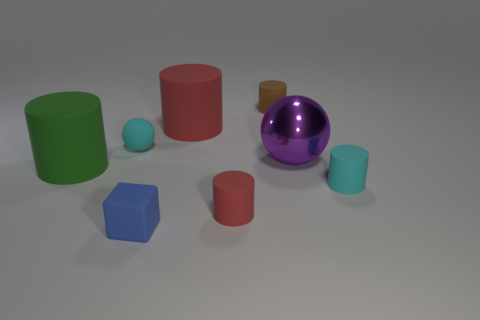Subtract all big red matte cylinders. How many cylinders are left? 4 Subtract all red cylinders. How many cylinders are left? 3 Add 2 balls. How many objects exist? 10 Subtract 2 cylinders. How many cylinders are left? 3 Subtract all spheres. How many objects are left? 6 Subtract all brown blocks. Subtract all purple cylinders. How many blocks are left? 1 Subtract all red balls. How many purple cubes are left? 0 Subtract all tiny matte blocks. Subtract all purple balls. How many objects are left? 6 Add 7 big green matte things. How many big green matte things are left? 8 Add 5 tiny matte blocks. How many tiny matte blocks exist? 6 